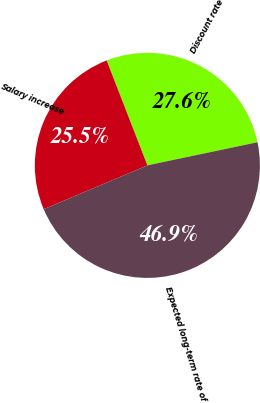<chart> <loc_0><loc_0><loc_500><loc_500><pie_chart><fcel>Discount rate<fcel>Salary increase<fcel>Expected long-term rate of<nl><fcel>27.6%<fcel>25.47%<fcel>46.93%<nl></chart> 